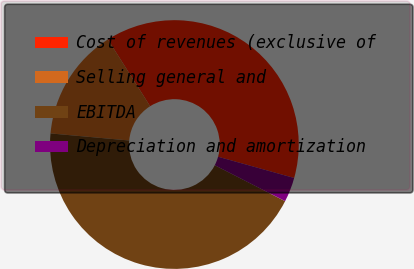Convert chart. <chart><loc_0><loc_0><loc_500><loc_500><pie_chart><fcel>Cost of revenues (exclusive of<fcel>Selling general and<fcel>EBITDA<fcel>Depreciation and amortization<nl><fcel>38.31%<fcel>14.6%<fcel>43.9%<fcel>3.19%<nl></chart> 